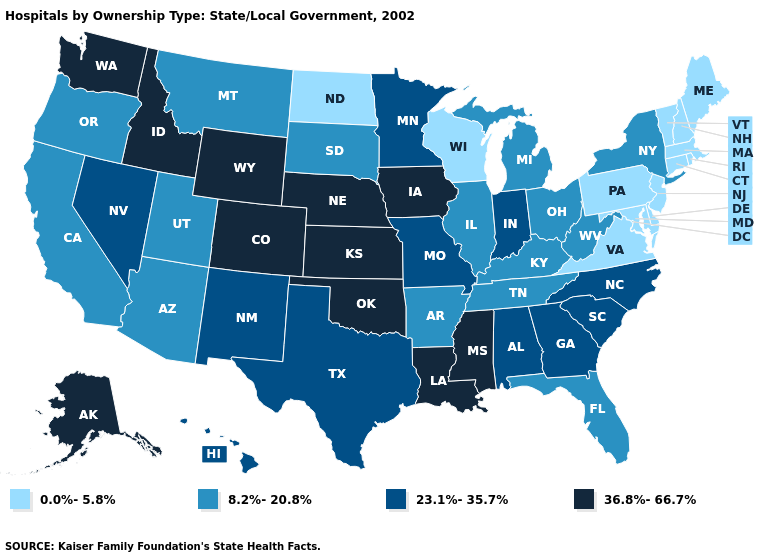What is the value of Alabama?
Concise answer only. 23.1%-35.7%. What is the value of Wisconsin?
Answer briefly. 0.0%-5.8%. What is the value of Connecticut?
Give a very brief answer. 0.0%-5.8%. Which states hav the highest value in the MidWest?
Answer briefly. Iowa, Kansas, Nebraska. How many symbols are there in the legend?
Concise answer only. 4. Among the states that border Washington , does Oregon have the highest value?
Answer briefly. No. What is the value of Mississippi?
Quick response, please. 36.8%-66.7%. What is the highest value in the USA?
Answer briefly. 36.8%-66.7%. Among the states that border Kansas , does Colorado have the highest value?
Answer briefly. Yes. Does the map have missing data?
Be succinct. No. Which states have the lowest value in the West?
Be succinct. Arizona, California, Montana, Oregon, Utah. What is the lowest value in the Northeast?
Answer briefly. 0.0%-5.8%. Name the states that have a value in the range 36.8%-66.7%?
Give a very brief answer. Alaska, Colorado, Idaho, Iowa, Kansas, Louisiana, Mississippi, Nebraska, Oklahoma, Washington, Wyoming. What is the value of Colorado?
Concise answer only. 36.8%-66.7%. How many symbols are there in the legend?
Give a very brief answer. 4. 